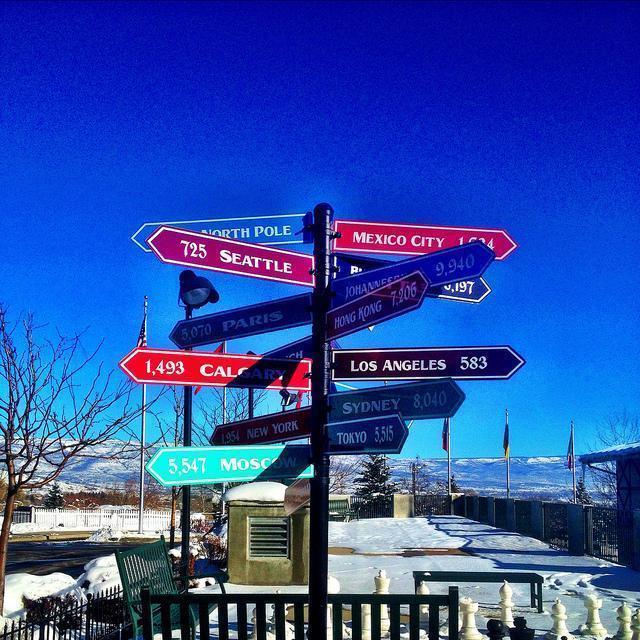What kind of locations are mentioned in the signs?
Select the accurate answer and provide explanation: 'Answer: answer
Rationale: rationale.'
Options: Continents, countries, cities, cardinal points. Answer: cities.
Rationale: The colored signs all have the names of different cities and pointing in their direction. 